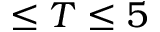Convert formula to latex. <formula><loc_0><loc_0><loc_500><loc_500>\leq T \leq 5</formula> 